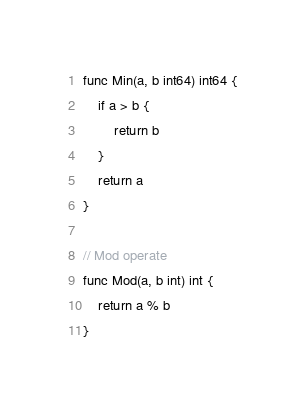<code> <loc_0><loc_0><loc_500><loc_500><_Go_>func Min(a, b int64) int64 {
	if a > b {
		return b
	}
	return a
}

// Mod operate
func Mod(a, b int) int {
	return a % b
}
</code> 